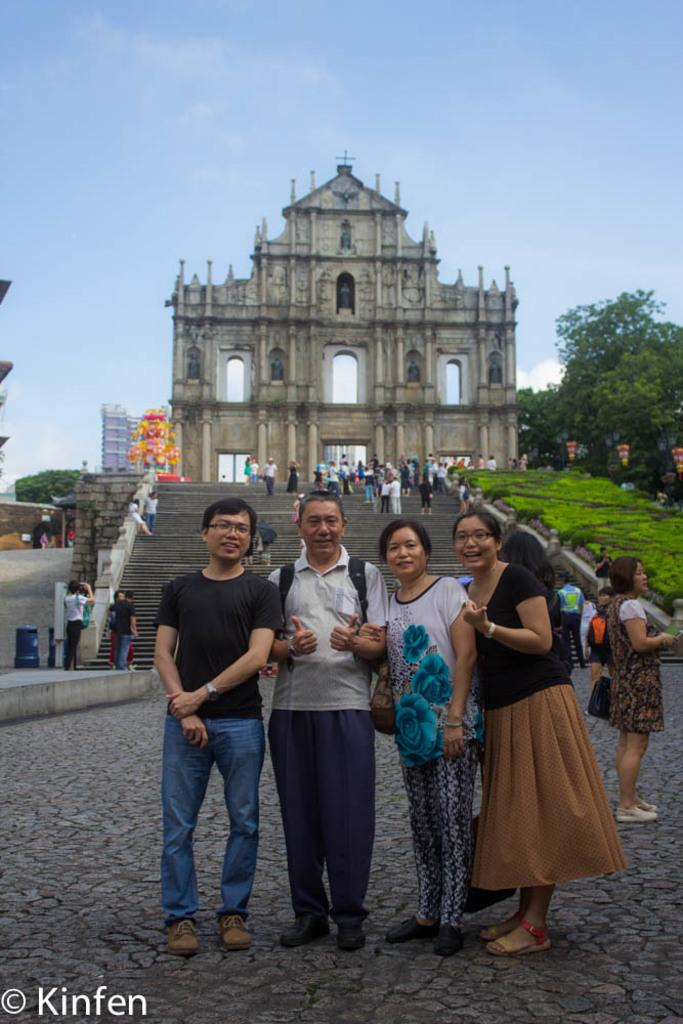What are the persons in the image doing? The persons in the image are standing on the road and on a staircase. What structure can be seen in the image? There is an arch in the image. What type of vegetation is present in the image? There are trees in the image. What objects are present for waste disposal? There are trash bins in the image. What is visible in the background of the image? The sky is visible in the background of the image, and there are clouds in the sky. What type of van can be seen parked near the persons in the image? There is no van present in the image. What is the reaction of the persons to the sudden appearance of a mouth in the sky? There is no mouth present in the sky in the image. 